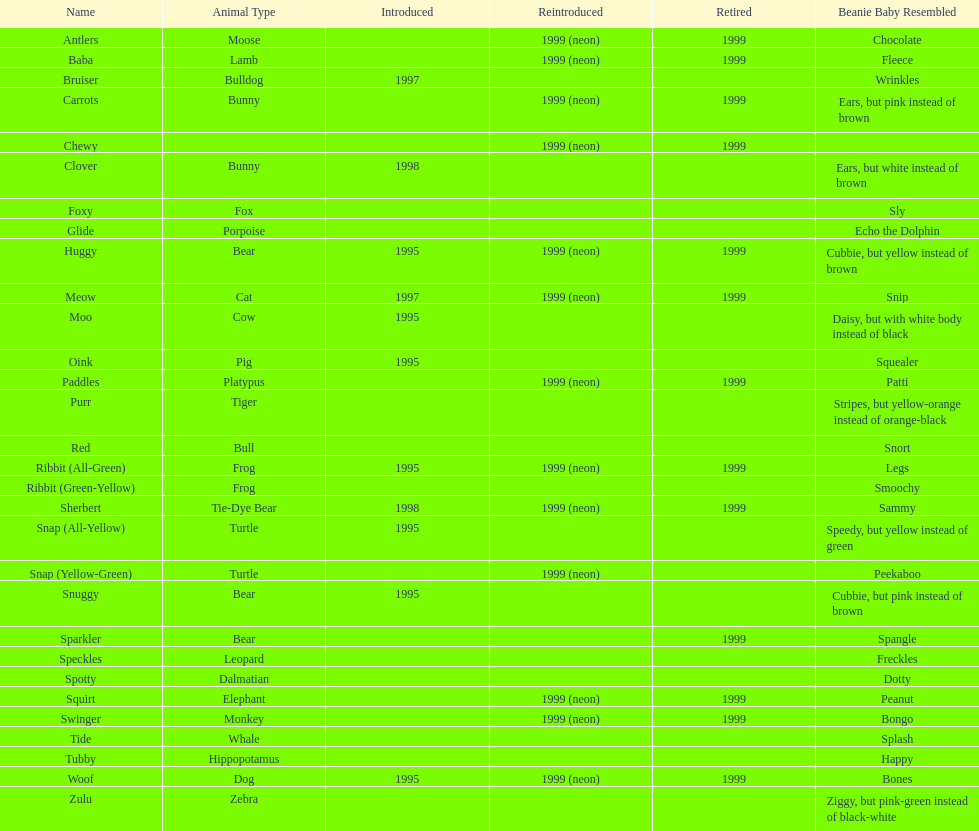Tell me the number of pillow pals reintroduced in 1999. 13. 